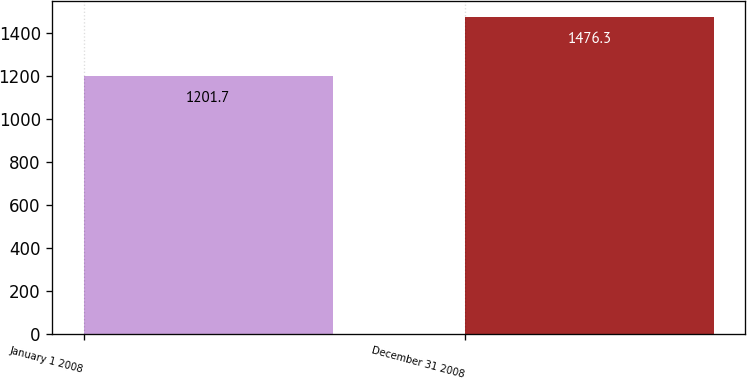<chart> <loc_0><loc_0><loc_500><loc_500><bar_chart><fcel>January 1 2008<fcel>December 31 2008<nl><fcel>1201.7<fcel>1476.3<nl></chart> 